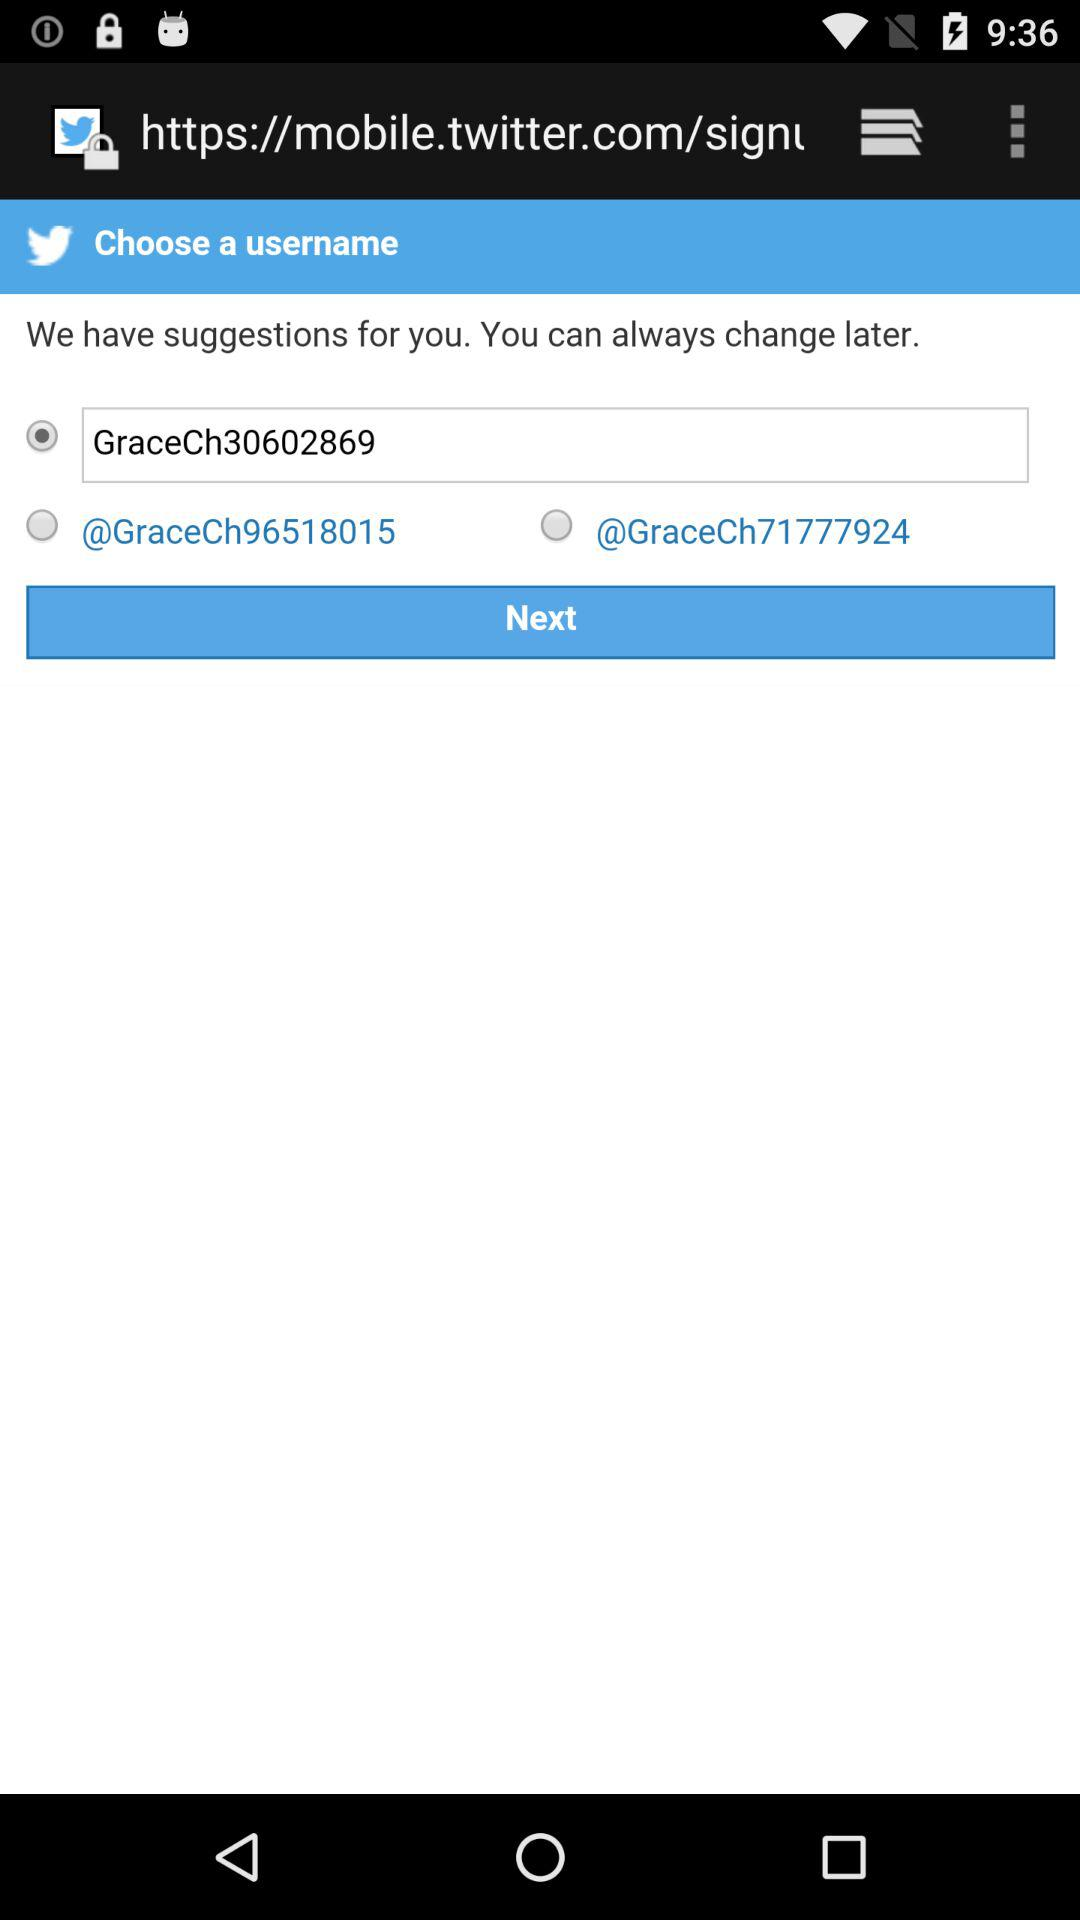Which version of the application is this?
When the provided information is insufficient, respond with <no answer>. <no answer> 